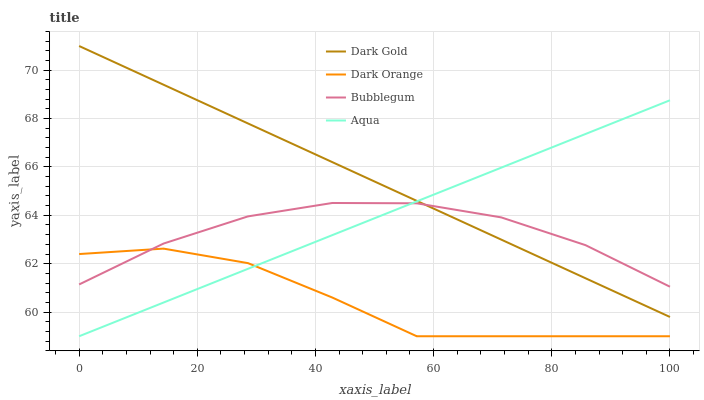Does Dark Orange have the minimum area under the curve?
Answer yes or no. Yes. Does Dark Gold have the maximum area under the curve?
Answer yes or no. Yes. Does Aqua have the minimum area under the curve?
Answer yes or no. No. Does Aqua have the maximum area under the curve?
Answer yes or no. No. Is Dark Gold the smoothest?
Answer yes or no. Yes. Is Dark Orange the roughest?
Answer yes or no. Yes. Is Aqua the smoothest?
Answer yes or no. No. Is Aqua the roughest?
Answer yes or no. No. Does Dark Orange have the lowest value?
Answer yes or no. Yes. Does Bubblegum have the lowest value?
Answer yes or no. No. Does Dark Gold have the highest value?
Answer yes or no. Yes. Does Aqua have the highest value?
Answer yes or no. No. Is Dark Orange less than Dark Gold?
Answer yes or no. Yes. Is Dark Gold greater than Dark Orange?
Answer yes or no. Yes. Does Aqua intersect Dark Gold?
Answer yes or no. Yes. Is Aqua less than Dark Gold?
Answer yes or no. No. Is Aqua greater than Dark Gold?
Answer yes or no. No. Does Dark Orange intersect Dark Gold?
Answer yes or no. No. 